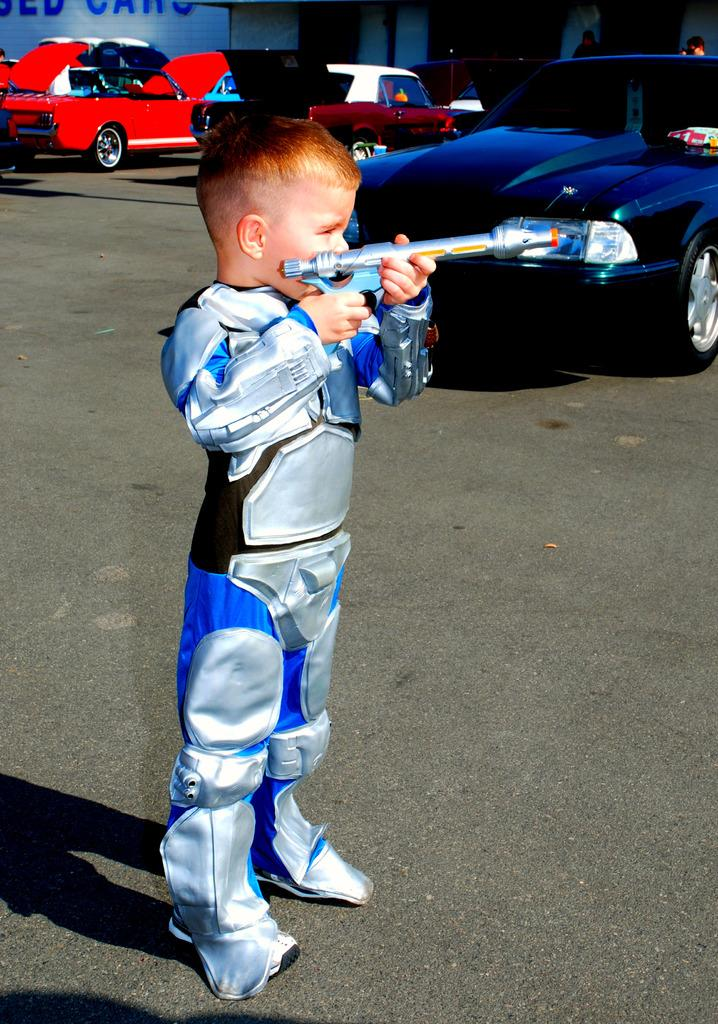Who is the main subject in the image? There is a boy in the image. What is the boy doing in the image? The boy is standing. What is the boy wearing in the image? The boy is wearing a blue, shining dress. What can be seen on the right side of the road in the image? There is a black car parked on the right side of the road in the image. What type of bait is the boy using to catch fish in the image? There is no indication in the image that the boy is fishing or using bait; he is simply standing and wearing a blue, shining dress. 